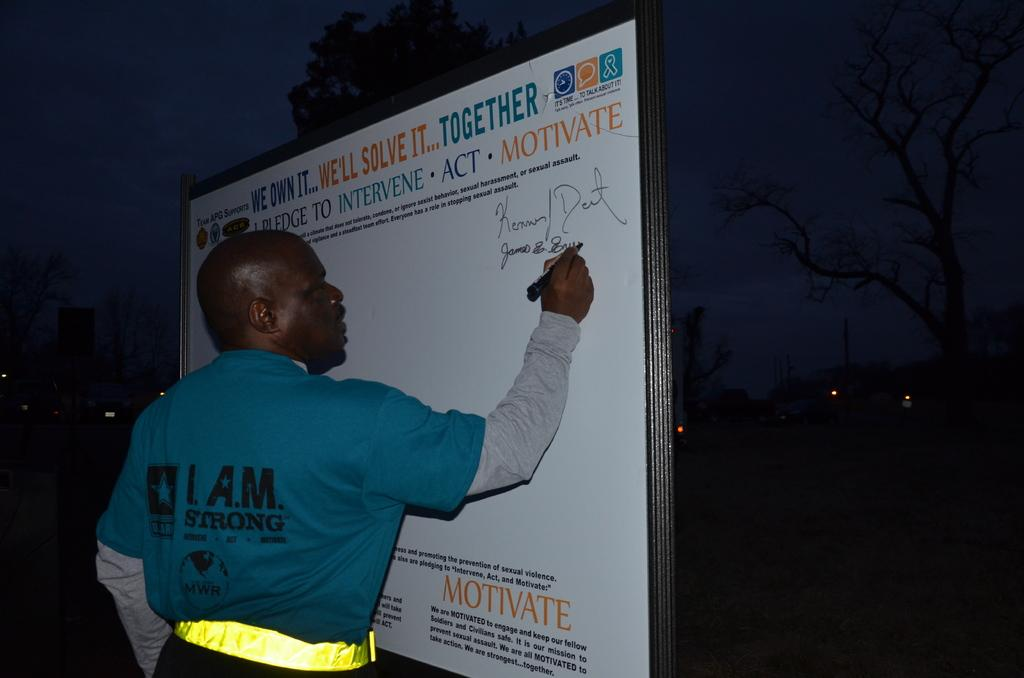What is the main subject of the picture? There is a person in the center of the picture. What is the person doing in the image? The person is writing on a board. What can be seen on the board? There is text on the board. What is visible in the background of the image? There are trees and lights in the background of the image. How would you describe the sky in the image? The sky is dark in the image. What type of science is being discussed by the committee in the image? There is no committee present in the image, and no scientific discussion is taking place. Can you see a hen in the image? There is no hen present in the image. 